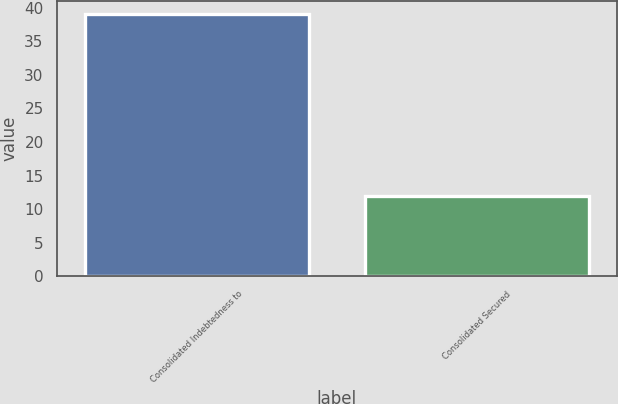Convert chart. <chart><loc_0><loc_0><loc_500><loc_500><bar_chart><fcel>Consolidated Indebtedness to<fcel>Consolidated Secured<nl><fcel>39<fcel>12<nl></chart> 